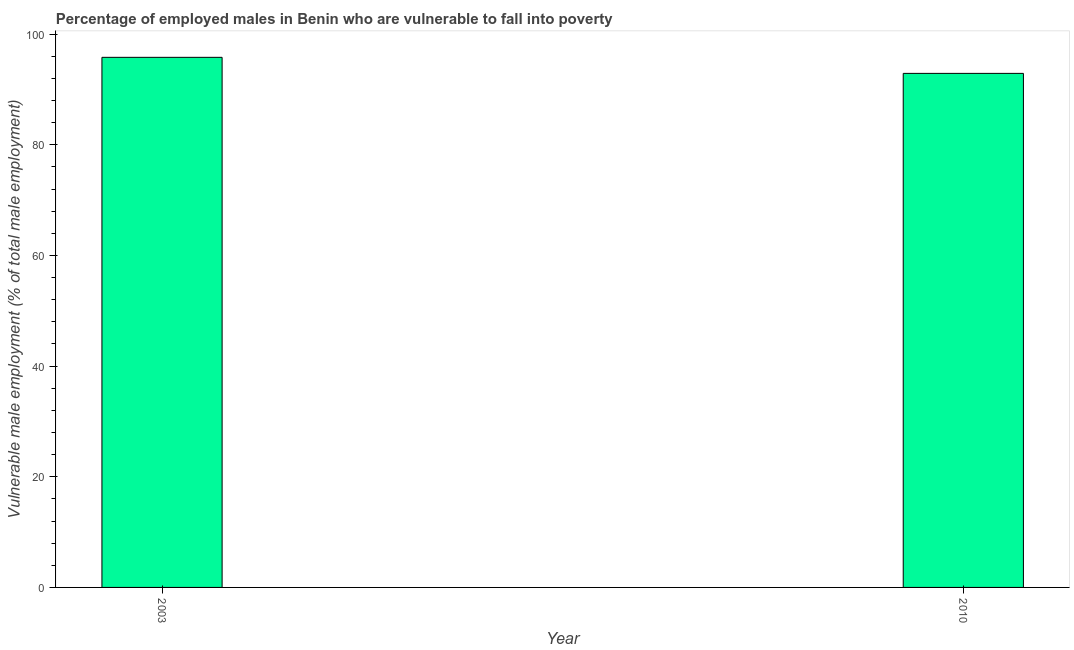Does the graph contain any zero values?
Your answer should be very brief. No. Does the graph contain grids?
Make the answer very short. No. What is the title of the graph?
Keep it short and to the point. Percentage of employed males in Benin who are vulnerable to fall into poverty. What is the label or title of the X-axis?
Your answer should be compact. Year. What is the label or title of the Y-axis?
Your response must be concise. Vulnerable male employment (% of total male employment). What is the percentage of employed males who are vulnerable to fall into poverty in 2003?
Keep it short and to the point. 95.8. Across all years, what is the maximum percentage of employed males who are vulnerable to fall into poverty?
Keep it short and to the point. 95.8. Across all years, what is the minimum percentage of employed males who are vulnerable to fall into poverty?
Your answer should be very brief. 92.9. In which year was the percentage of employed males who are vulnerable to fall into poverty maximum?
Provide a short and direct response. 2003. What is the sum of the percentage of employed males who are vulnerable to fall into poverty?
Offer a very short reply. 188.7. What is the average percentage of employed males who are vulnerable to fall into poverty per year?
Keep it short and to the point. 94.35. What is the median percentage of employed males who are vulnerable to fall into poverty?
Provide a succinct answer. 94.35. In how many years, is the percentage of employed males who are vulnerable to fall into poverty greater than 20 %?
Your answer should be very brief. 2. What is the ratio of the percentage of employed males who are vulnerable to fall into poverty in 2003 to that in 2010?
Keep it short and to the point. 1.03. Are all the bars in the graph horizontal?
Your answer should be very brief. No. How many years are there in the graph?
Your response must be concise. 2. What is the Vulnerable male employment (% of total male employment) of 2003?
Your answer should be very brief. 95.8. What is the Vulnerable male employment (% of total male employment) of 2010?
Keep it short and to the point. 92.9. What is the difference between the Vulnerable male employment (% of total male employment) in 2003 and 2010?
Ensure brevity in your answer.  2.9. What is the ratio of the Vulnerable male employment (% of total male employment) in 2003 to that in 2010?
Make the answer very short. 1.03. 